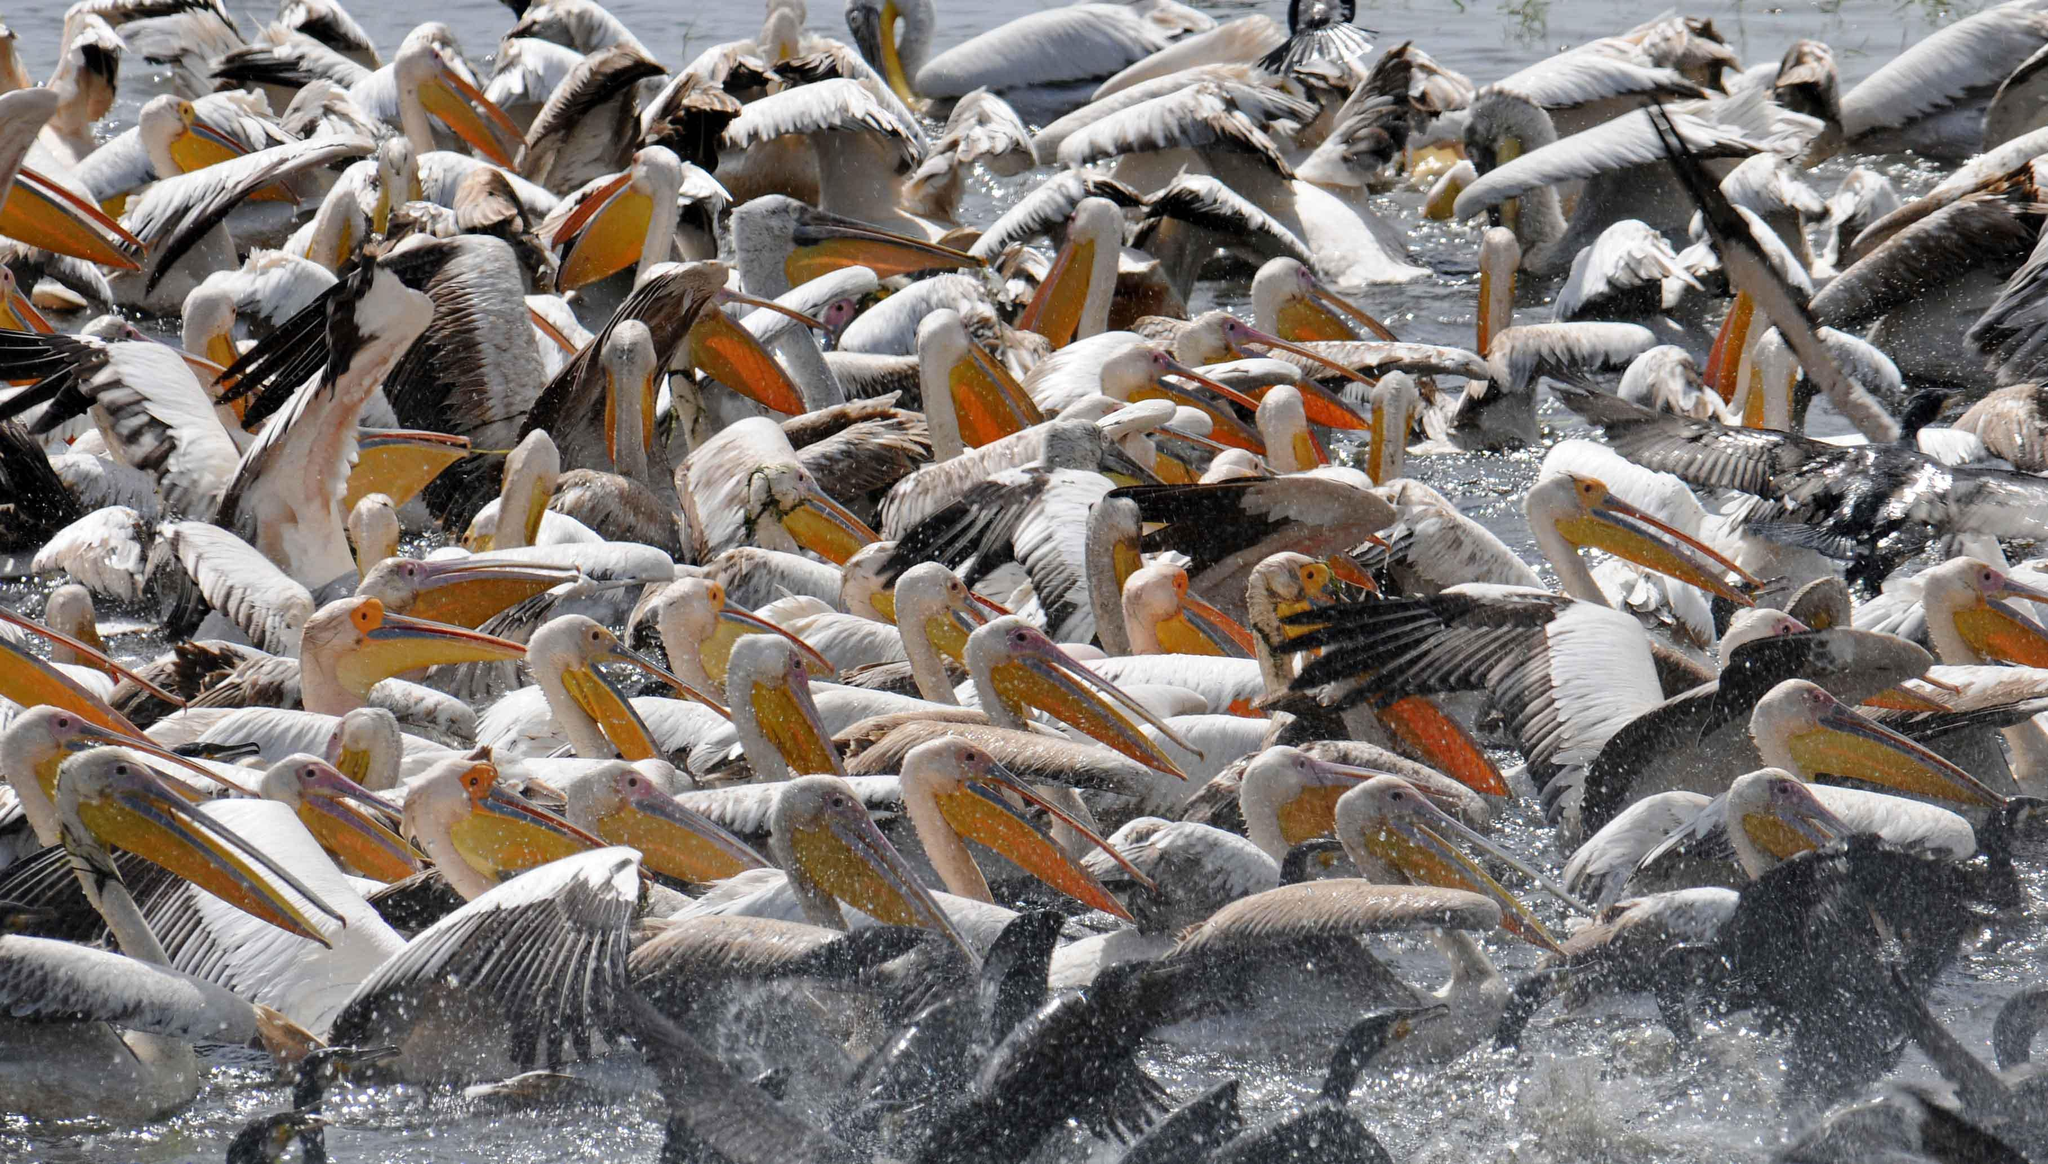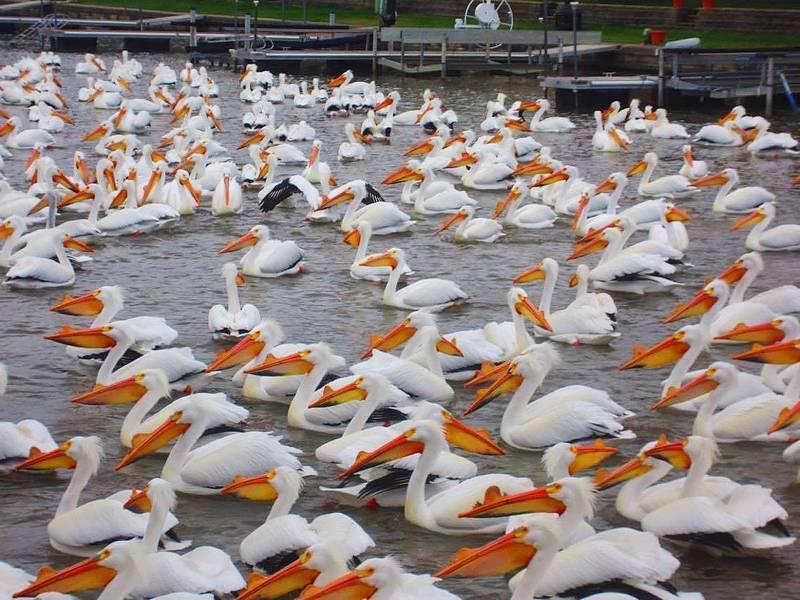The first image is the image on the left, the second image is the image on the right. Assess this claim about the two images: "In one image, nearly all pelicans in the foreground face leftward.". Correct or not? Answer yes or no. Yes. The first image is the image on the left, the second image is the image on the right. Assess this claim about the two images: "A few of the birds are in the air in one one the images.". Correct or not? Answer yes or no. No. 